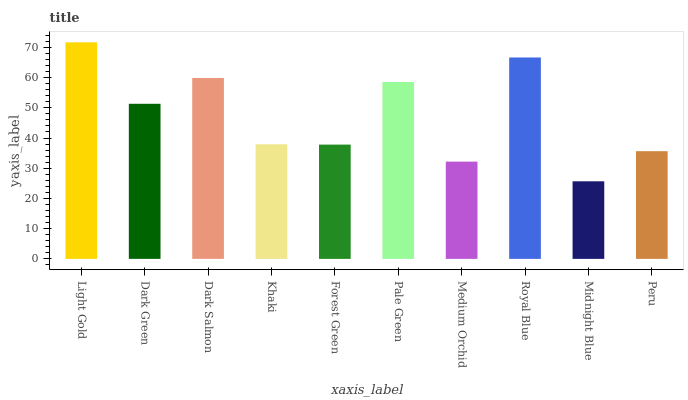Is Midnight Blue the minimum?
Answer yes or no. Yes. Is Light Gold the maximum?
Answer yes or no. Yes. Is Dark Green the minimum?
Answer yes or no. No. Is Dark Green the maximum?
Answer yes or no. No. Is Light Gold greater than Dark Green?
Answer yes or no. Yes. Is Dark Green less than Light Gold?
Answer yes or no. Yes. Is Dark Green greater than Light Gold?
Answer yes or no. No. Is Light Gold less than Dark Green?
Answer yes or no. No. Is Dark Green the high median?
Answer yes or no. Yes. Is Khaki the low median?
Answer yes or no. Yes. Is Midnight Blue the high median?
Answer yes or no. No. Is Dark Salmon the low median?
Answer yes or no. No. 